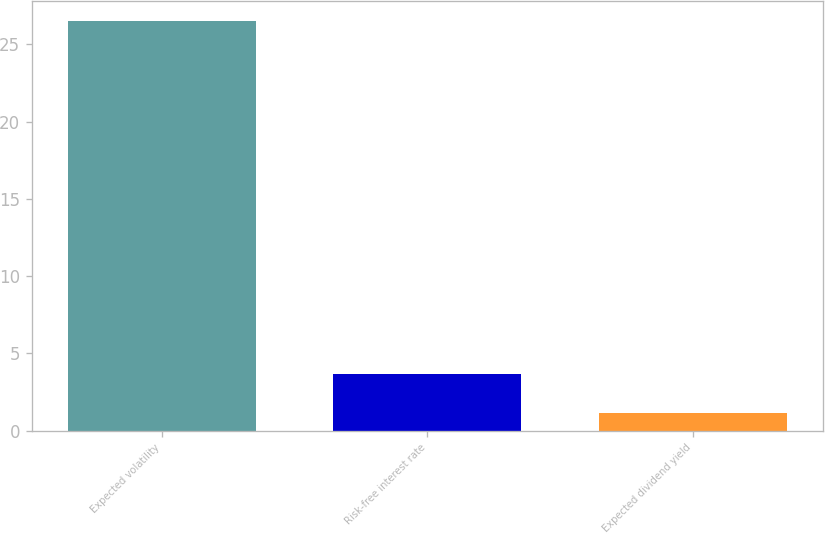<chart> <loc_0><loc_0><loc_500><loc_500><bar_chart><fcel>Expected volatility<fcel>Risk-free interest rate<fcel>Expected dividend yield<nl><fcel>26.5<fcel>3.66<fcel>1.12<nl></chart> 